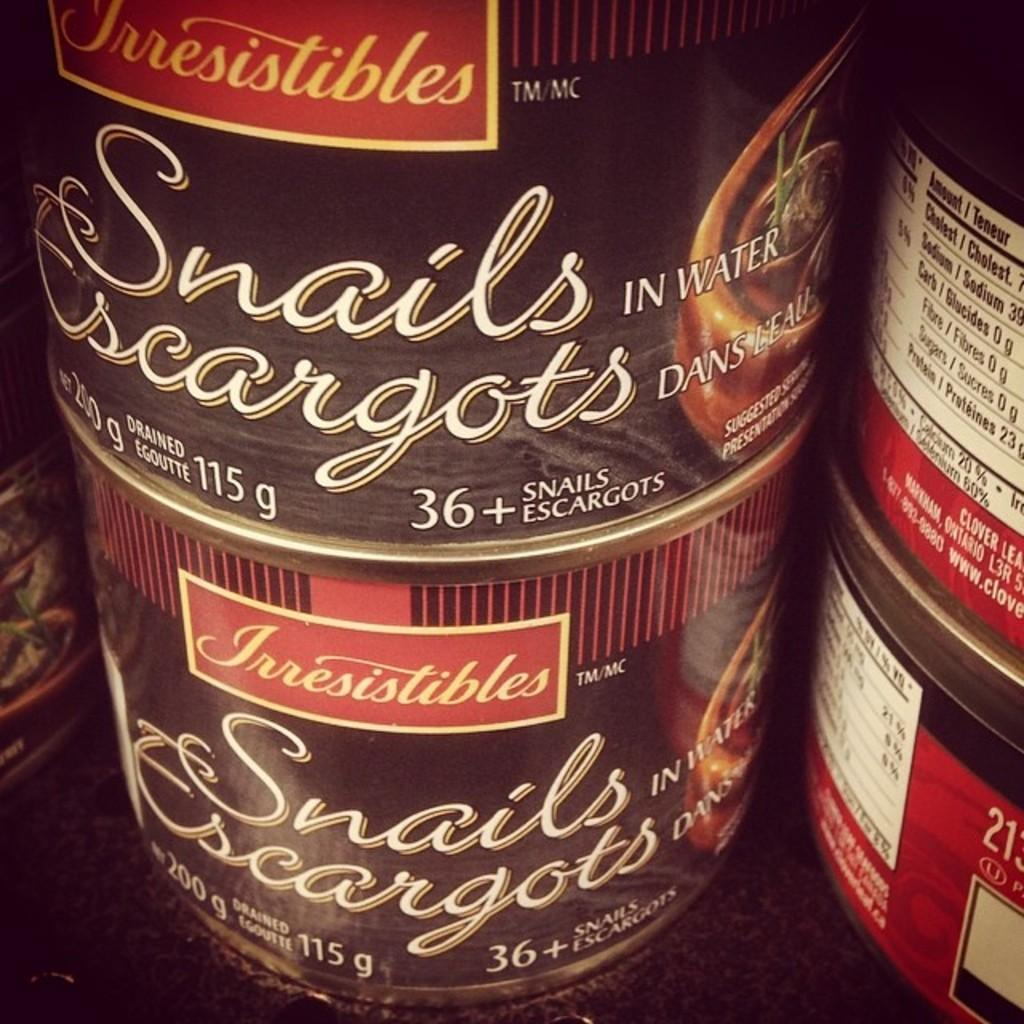What is located in the center of the image? There are boxes in the center of the image. What is written on the boxes? The boxes have the words "Snails Escargots" written on them. Are there any other words or text on the boxes? Yes, there is text on the boxes. What type of key is used to unlock the liquid inside the boxes? There is no key or liquid present in the image; it only features boxes with text. 